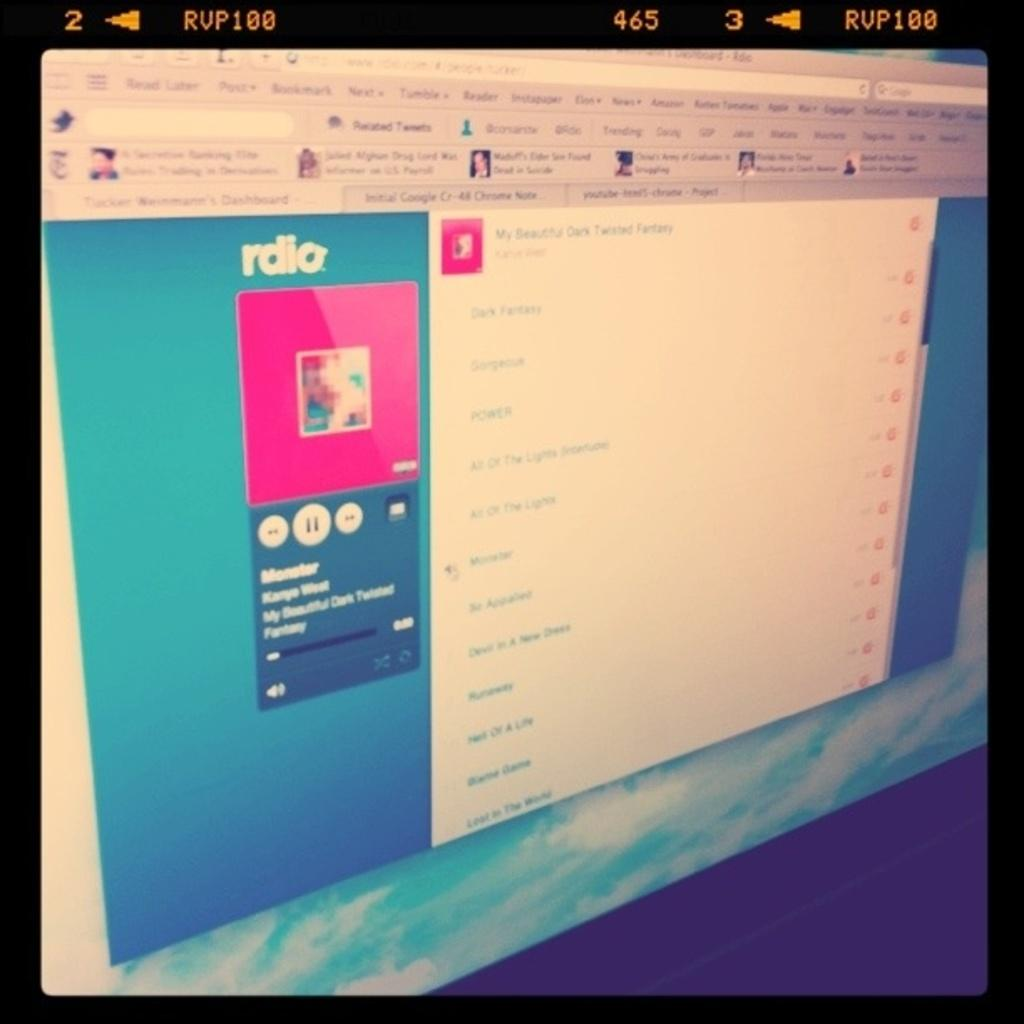<image>
Write a terse but informative summary of the picture. A computer screen open to the "rdio" website. 